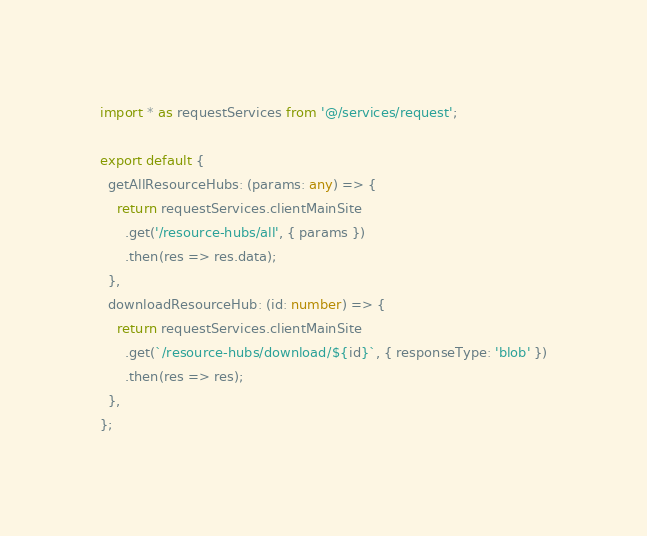Convert code to text. <code><loc_0><loc_0><loc_500><loc_500><_TypeScript_>import * as requestServices from '@/services/request';

export default {
  getAllResourceHubs: (params: any) => {
    return requestServices.clientMainSite
      .get('/resource-hubs/all', { params })
      .then(res => res.data);
  },
  downloadResourceHub: (id: number) => {
    return requestServices.clientMainSite
      .get(`/resource-hubs/download/${id}`, { responseType: 'blob' })
      .then(res => res);
  },
};
</code> 